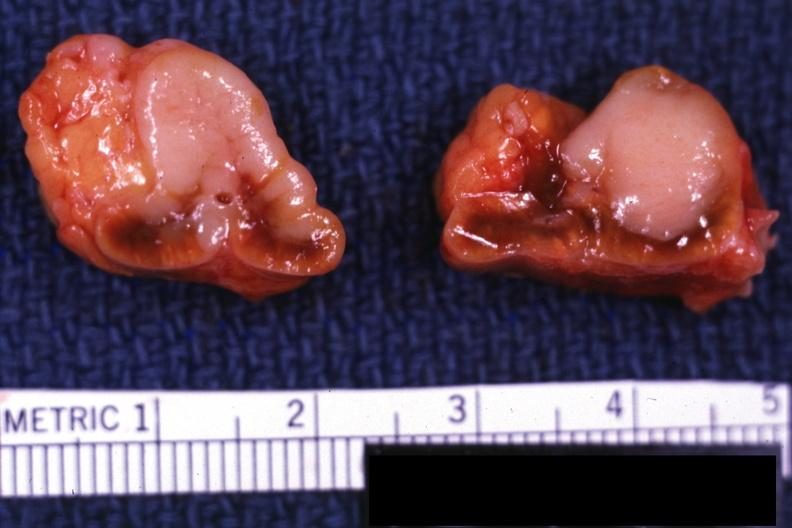s adrenal present?
Answer the question using a single word or phrase. Yes 